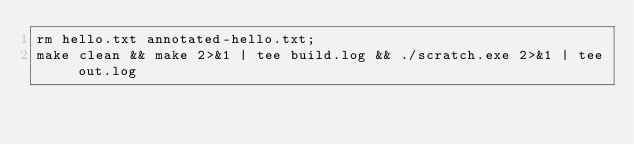<code> <loc_0><loc_0><loc_500><loc_500><_Bash_>rm hello.txt annotated-hello.txt;
make clean && make 2>&1 | tee build.log && ./scratch.exe 2>&1 | tee out.log 
</code> 